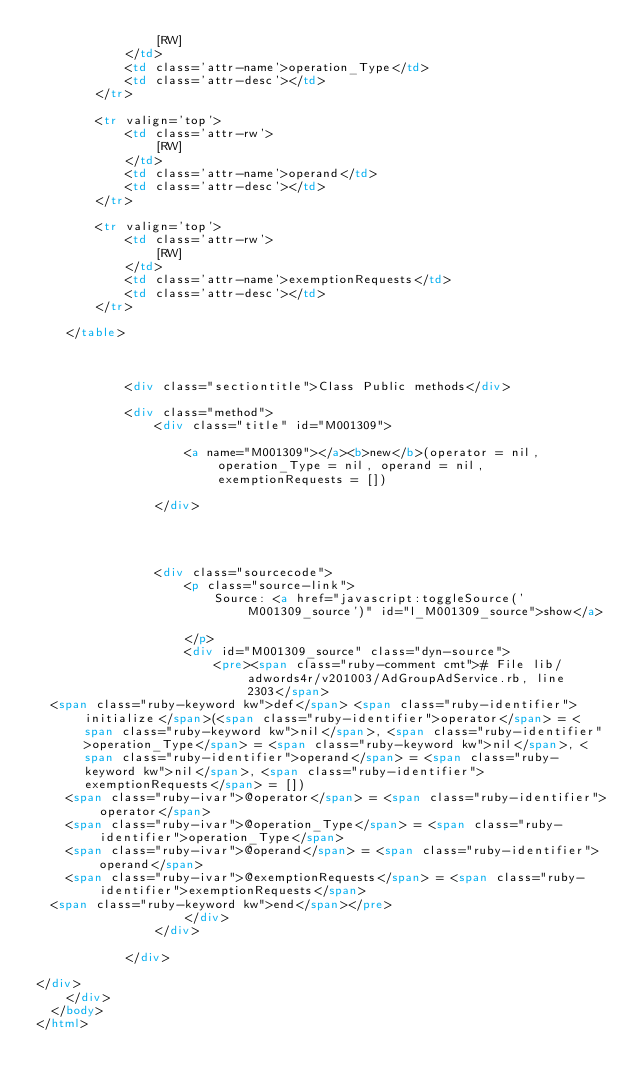<code> <loc_0><loc_0><loc_500><loc_500><_HTML_>                [RW]
            </td>
            <td class='attr-name'>operation_Type</td>
            <td class='attr-desc'></td>
        </tr>
        
        <tr valign='top'>
            <td class='attr-rw'>
                [RW]
            </td>
            <td class='attr-name'>operand</td>
            <td class='attr-desc'></td>
        </tr>
        
        <tr valign='top'>
            <td class='attr-rw'>
                [RW]
            </td>
            <td class='attr-name'>exemptionRequests</td>
            <td class='attr-desc'></td>
        </tr>
        
    </table>
    

    
            <div class="sectiontitle">Class Public methods</div>
            
            <div class="method">
                <div class="title" id="M001309">
                    
                    <a name="M001309"></a><b>new</b>(operator = nil, operation_Type = nil, operand = nil, exemptionRequests = [])
                    
                </div>
                
                
                
                
                <div class="sourcecode">
                    <p class="source-link">
                        Source: <a href="javascript:toggleSource('M001309_source')" id="l_M001309_source">show</a>
                        
                    </p>
                    <div id="M001309_source" class="dyn-source">
                        <pre><span class="ruby-comment cmt"># File lib/adwords4r/v201003/AdGroupAdService.rb, line 2303</span>
  <span class="ruby-keyword kw">def</span> <span class="ruby-identifier">initialize</span>(<span class="ruby-identifier">operator</span> = <span class="ruby-keyword kw">nil</span>, <span class="ruby-identifier">operation_Type</span> = <span class="ruby-keyword kw">nil</span>, <span class="ruby-identifier">operand</span> = <span class="ruby-keyword kw">nil</span>, <span class="ruby-identifier">exemptionRequests</span> = [])
    <span class="ruby-ivar">@operator</span> = <span class="ruby-identifier">operator</span>
    <span class="ruby-ivar">@operation_Type</span> = <span class="ruby-identifier">operation_Type</span>
    <span class="ruby-ivar">@operand</span> = <span class="ruby-identifier">operand</span>
    <span class="ruby-ivar">@exemptionRequests</span> = <span class="ruby-identifier">exemptionRequests</span>
  <span class="ruby-keyword kw">end</span></pre>
                    </div>
                </div>
                
            </div>
            
</div>
    </div>
  </body>
</html>    </code> 